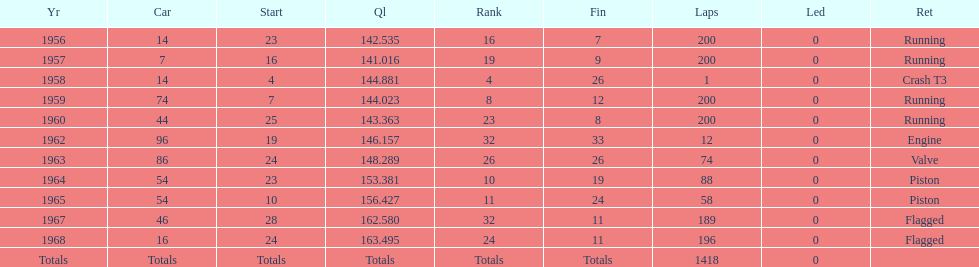What was the last year that it finished the race? 1968. 